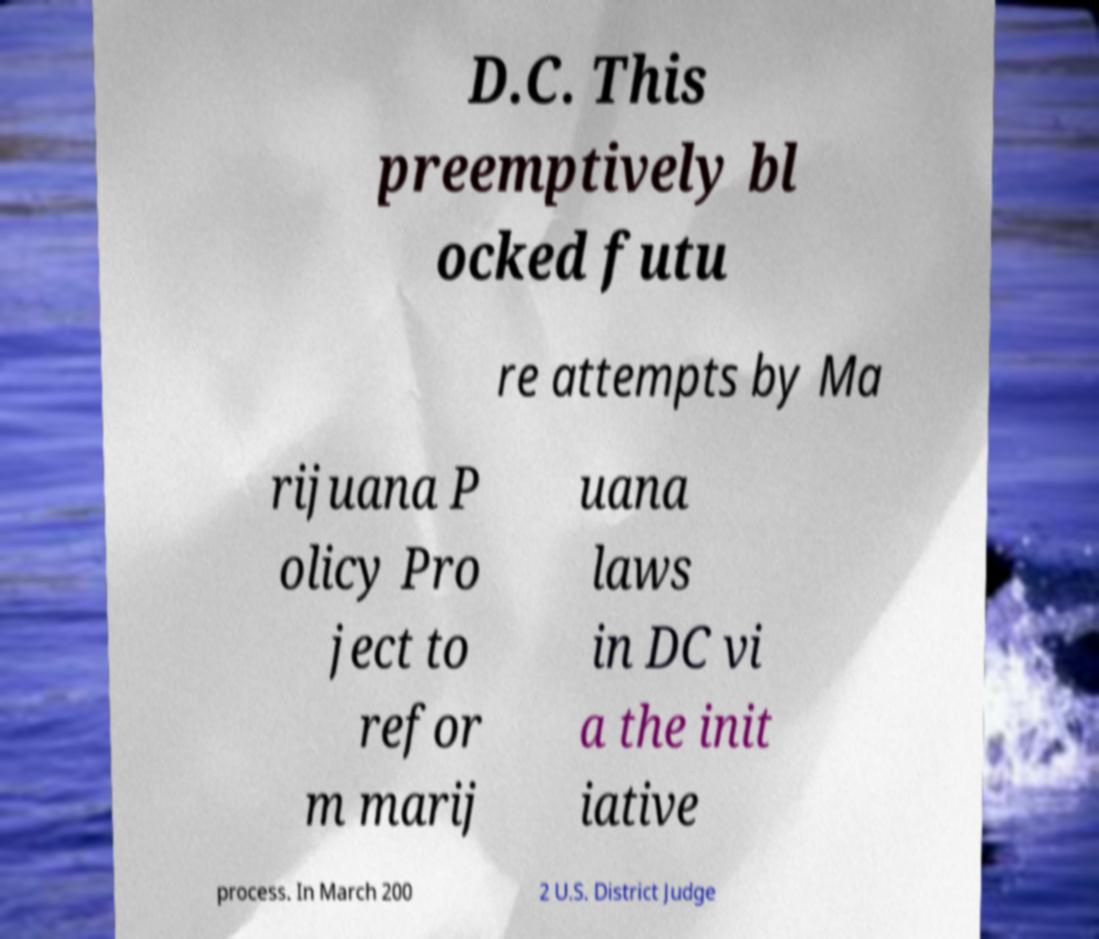What messages or text are displayed in this image? I need them in a readable, typed format. D.C. This preemptively bl ocked futu re attempts by Ma rijuana P olicy Pro ject to refor m marij uana laws in DC vi a the init iative process. In March 200 2 U.S. District Judge 